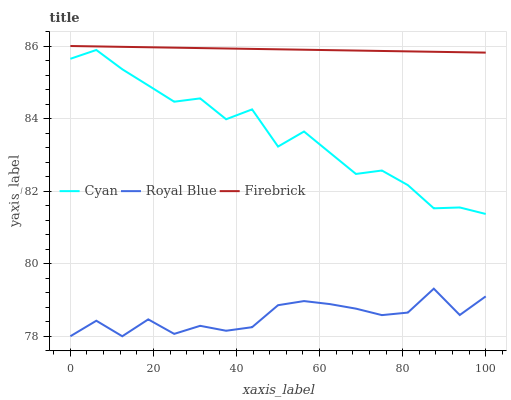Does Royal Blue have the minimum area under the curve?
Answer yes or no. Yes. Does Firebrick have the maximum area under the curve?
Answer yes or no. Yes. Does Firebrick have the minimum area under the curve?
Answer yes or no. No. Does Royal Blue have the maximum area under the curve?
Answer yes or no. No. Is Firebrick the smoothest?
Answer yes or no. Yes. Is Cyan the roughest?
Answer yes or no. Yes. Is Royal Blue the smoothest?
Answer yes or no. No. Is Royal Blue the roughest?
Answer yes or no. No. Does Firebrick have the lowest value?
Answer yes or no. No. Does Firebrick have the highest value?
Answer yes or no. Yes. Does Royal Blue have the highest value?
Answer yes or no. No. Is Royal Blue less than Cyan?
Answer yes or no. Yes. Is Firebrick greater than Cyan?
Answer yes or no. Yes. Does Royal Blue intersect Cyan?
Answer yes or no. No. 